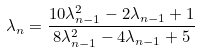Convert formula to latex. <formula><loc_0><loc_0><loc_500><loc_500>\lambda _ { n } = \frac { 1 0 \lambda _ { n - 1 } ^ { 2 } - 2 \lambda _ { n - 1 } + 1 } { 8 \lambda _ { n - 1 } ^ { 2 } - 4 \lambda _ { n - 1 } + 5 }</formula> 